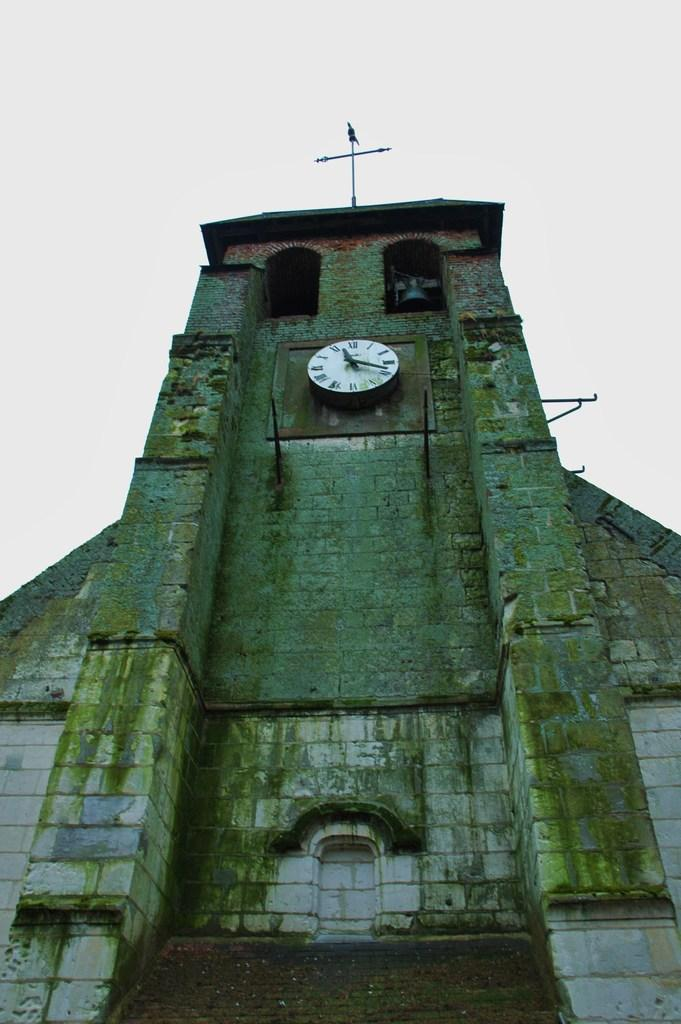What structure is depicted in the image? There is a building in the image. What is attached to the building? There is a wall clock on the building and a compass on top of the building. What can be seen in the background of the image? The sky is visible in the image. What type of joke is the woman telling in the image? There is no woman present in the image, and therefore no joke-telling can be observed. Can you describe the sail that is attached to the building? There is no sail attached to the building in the image. 